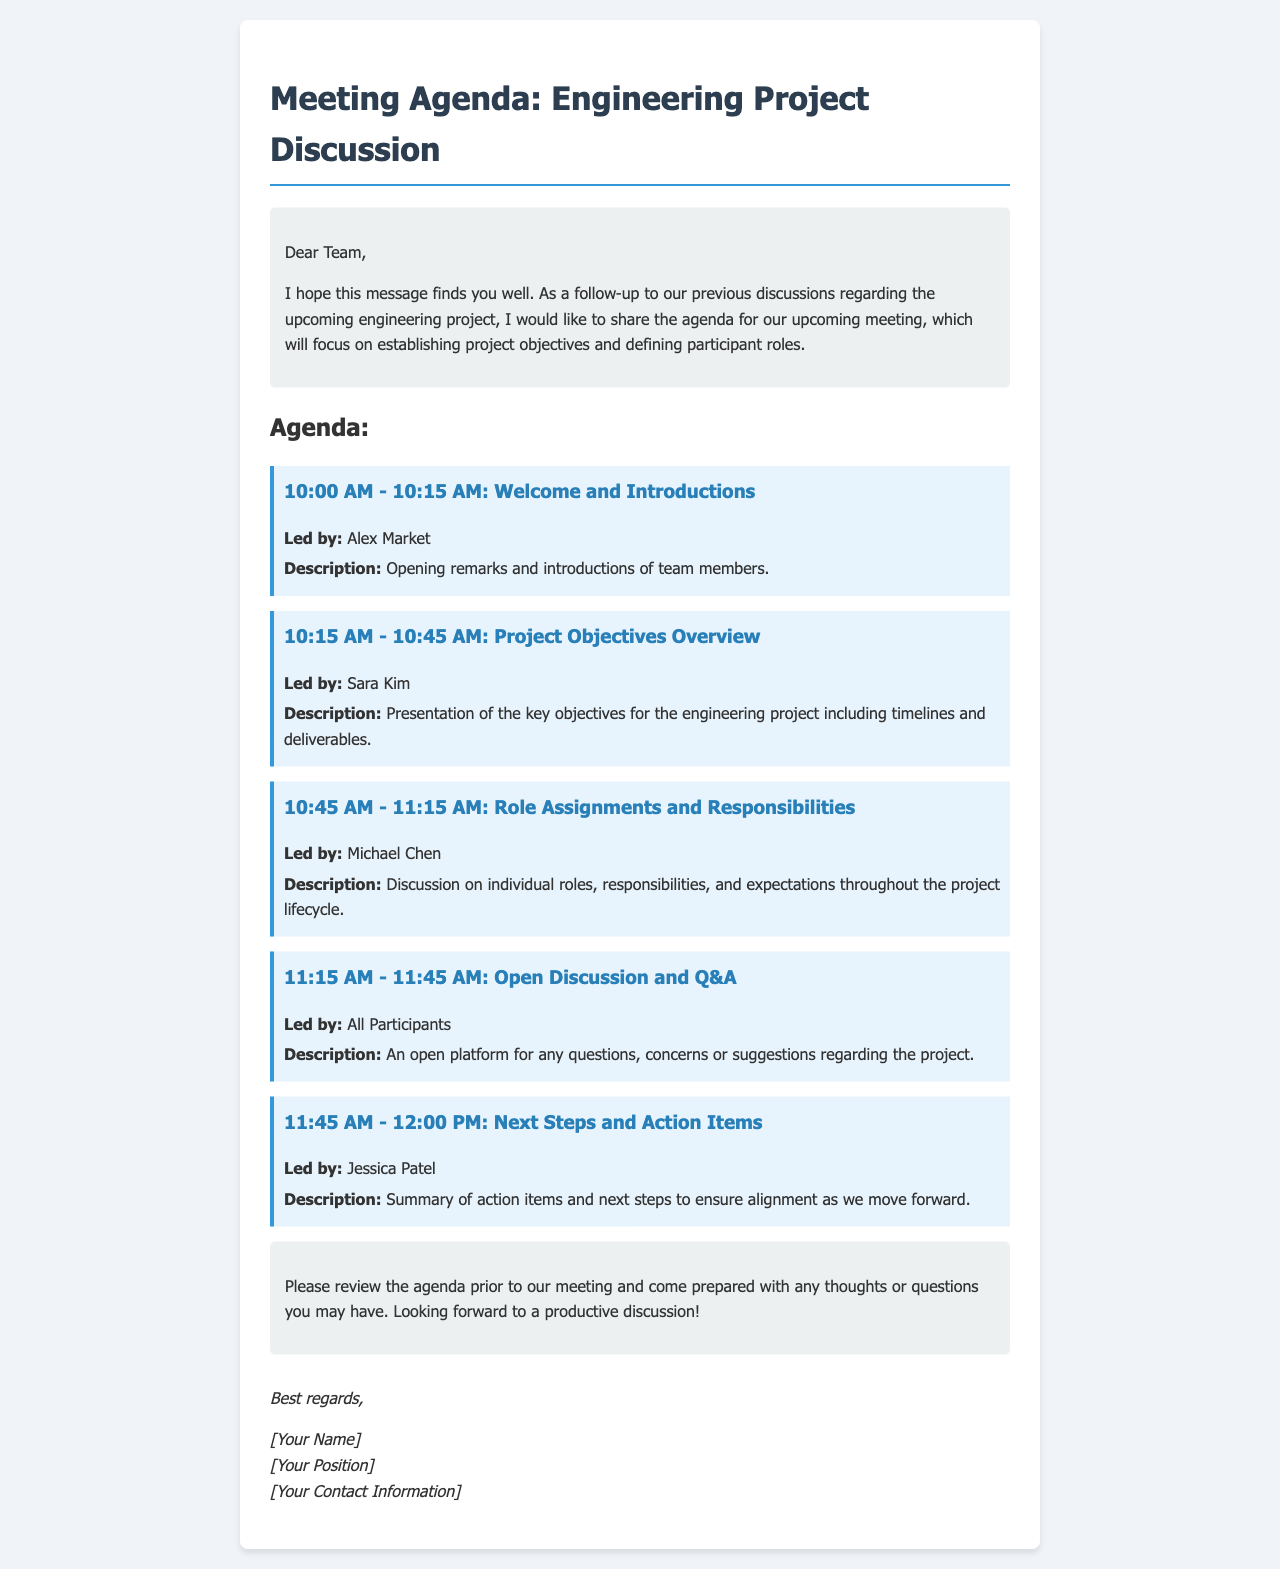What time does the meeting start? The meeting starts at 10:00 AM according to the agenda provided.
Answer: 10:00 AM Who is responsible for the Role Assignments and Responsibilities segment? The agenda specifies that Michael Chen will lead the Role Assignments and Responsibilities discussion.
Answer: Michael Chen What is the duration of the Open Discussion and Q&A? The Open Discussion and Q&A point is scheduled for 30 minutes, from 11:15 AM to 11:45 AM.
Answer: 30 minutes What is one of the key objectives mentioned in the meeting? The meeting agenda indicates that the key objectives involve timelines and deliverables, as introduced by Sara Kim.
Answer: Timelines and deliverables What should participants do prior to the meeting? The introduction section of the email advises participants to review the agenda before the meeting.
Answer: Review the agenda Who will summarize action items at the end of the meeting? Jessica Patel is designated to lead the summary of action items and next steps in the meeting.
Answer: Jessica Patel What is the nature of the final discussion in the agenda? The last agenda item involves summarizing action items and outlining next steps, which is an essential part of the meeting.
Answer: Action items and next steps Which role does Alex Market play in the meeting? Alex Market is leading the Welcome and Introductions segment at the beginning of the meeting.
Answer: Welcome and Introductions 